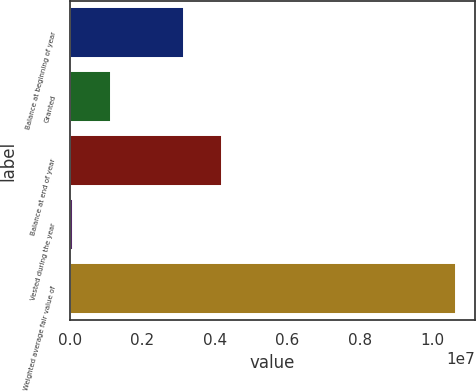Convert chart. <chart><loc_0><loc_0><loc_500><loc_500><bar_chart><fcel>Balance at beginning of year<fcel>Granted<fcel>Balance at end of year<fcel>Vested during the year<fcel>Weighted average fair value of<nl><fcel>3.13788e+06<fcel>1.14045e+06<fcel>4.19451e+06<fcel>83822<fcel>1.06501e+07<nl></chart> 